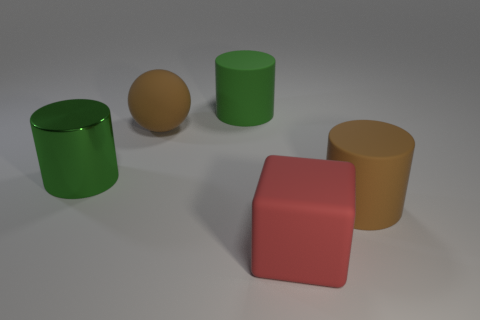Subtract all large green cylinders. How many cylinders are left? 1 Subtract all yellow balls. How many green cylinders are left? 2 Add 4 large green cylinders. How many objects exist? 9 Subtract all brown cylinders. How many cylinders are left? 2 Subtract 2 cylinders. How many cylinders are left? 1 Subtract all blocks. How many objects are left? 4 Add 4 brown rubber spheres. How many brown rubber spheres exist? 5 Subtract 1 brown spheres. How many objects are left? 4 Subtract all brown blocks. Subtract all brown balls. How many blocks are left? 1 Subtract all large cubes. Subtract all brown matte objects. How many objects are left? 2 